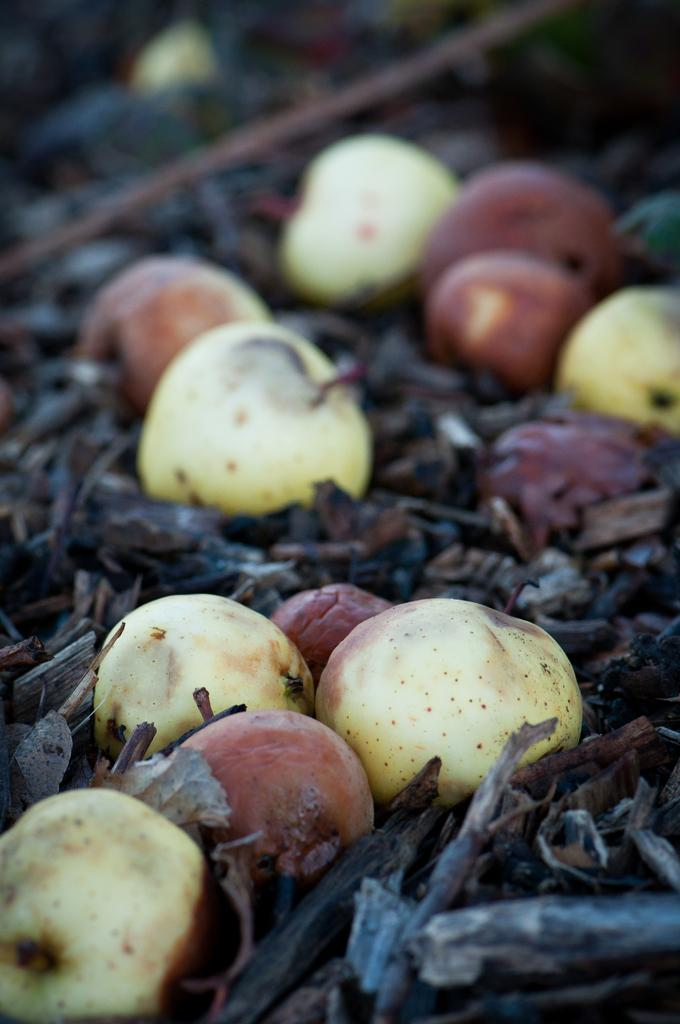What type of food items are present in the image? There are fruits in the image. How are the fruits arranged or displayed in the image? The fruits are on dry leaves and stems. Is there an umbrella visible in the image? No, there is no umbrella present in the image. Can you see a skateboard being used by someone in the image? No, there is no skateboard or person using it in the image. 